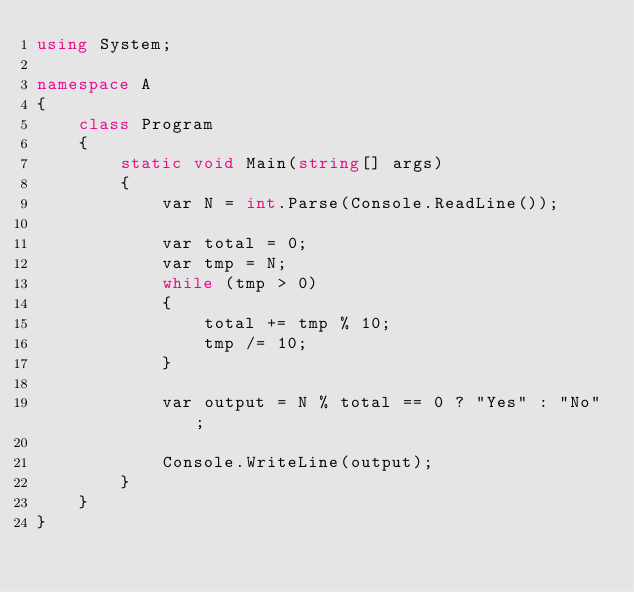<code> <loc_0><loc_0><loc_500><loc_500><_C#_>using System;

namespace A
{
    class Program
    {
        static void Main(string[] args)
        {
            var N = int.Parse(Console.ReadLine());

            var total = 0;
            var tmp = N;
            while (tmp > 0)
            {
                total += tmp % 10;
                tmp /= 10;
            }

            var output = N % total == 0 ? "Yes" : "No";

            Console.WriteLine(output);
        }
    }
}
</code> 